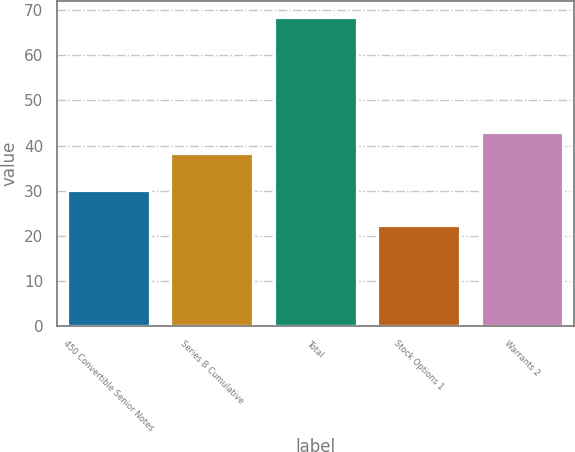Convert chart. <chart><loc_0><loc_0><loc_500><loc_500><bar_chart><fcel>450 Convertible Senior Notes<fcel>Series B Cumulative<fcel>Total<fcel>Stock Options 1<fcel>Warrants 2<nl><fcel>30.2<fcel>38.4<fcel>68.6<fcel>22.4<fcel>43.02<nl></chart> 